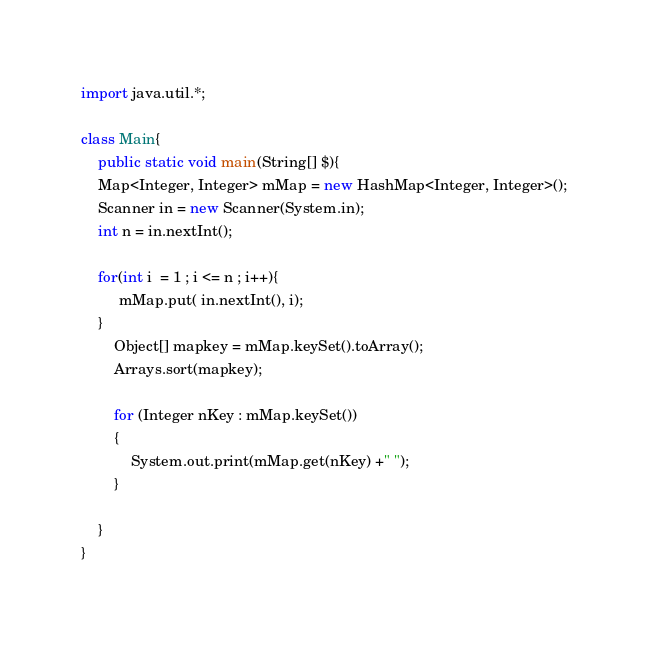<code> <loc_0><loc_0><loc_500><loc_500><_Java_>import java.util.*;

class Main{
	public static void main(String[] $){
    Map<Integer, Integer> mMap = new HashMap<Integer, Integer>();
    Scanner in = new Scanner(System.in);
    int n = in.nextInt();
    
    for(int i  = 1 ; i <= n ; i++){
         mMap.put( in.nextInt(), i);
    }
        Object[] mapkey = mMap.keySet().toArray();
        Arrays.sort(mapkey);
        
        for (Integer nKey : mMap.keySet())
        {
            System.out.print(mMap.get(nKey) +" ");
        }
		
	}
}
</code> 